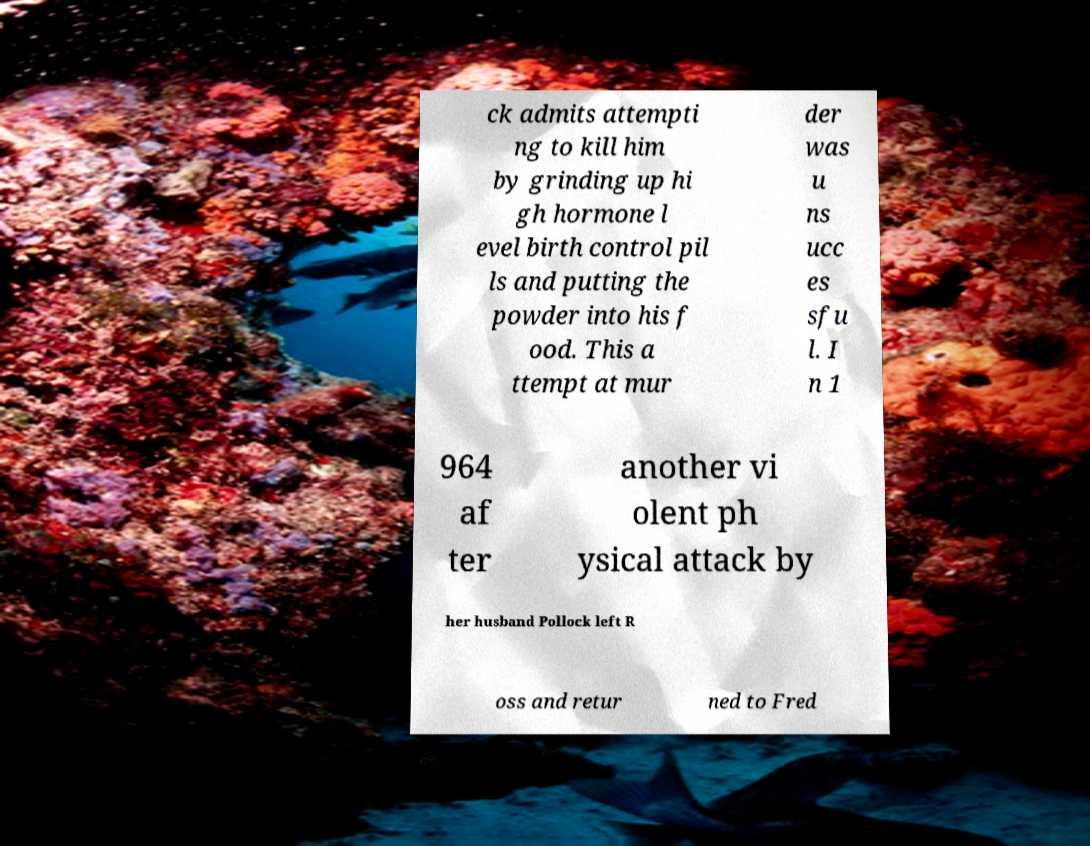What messages or text are displayed in this image? I need them in a readable, typed format. ck admits attempti ng to kill him by grinding up hi gh hormone l evel birth control pil ls and putting the powder into his f ood. This a ttempt at mur der was u ns ucc es sfu l. I n 1 964 af ter another vi olent ph ysical attack by her husband Pollock left R oss and retur ned to Fred 